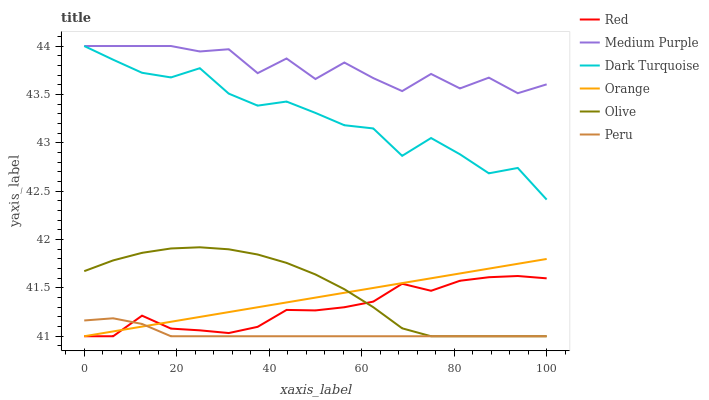Does Peru have the minimum area under the curve?
Answer yes or no. Yes. Does Medium Purple have the maximum area under the curve?
Answer yes or no. Yes. Does Olive have the minimum area under the curve?
Answer yes or no. No. Does Olive have the maximum area under the curve?
Answer yes or no. No. Is Orange the smoothest?
Answer yes or no. Yes. Is Medium Purple the roughest?
Answer yes or no. Yes. Is Olive the smoothest?
Answer yes or no. No. Is Olive the roughest?
Answer yes or no. No. Does Medium Purple have the lowest value?
Answer yes or no. No. Does Olive have the highest value?
Answer yes or no. No. Is Olive less than Dark Turquoise?
Answer yes or no. Yes. Is Medium Purple greater than Olive?
Answer yes or no. Yes. Does Olive intersect Dark Turquoise?
Answer yes or no. No. 